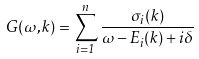Convert formula to latex. <formula><loc_0><loc_0><loc_500><loc_500>G ( \omega , { k } ) = \sum _ { i = 1 } ^ { n } \frac { \sigma _ { i } ( { k } ) } { \omega - E _ { i } ( { k } ) + i \delta }</formula> 